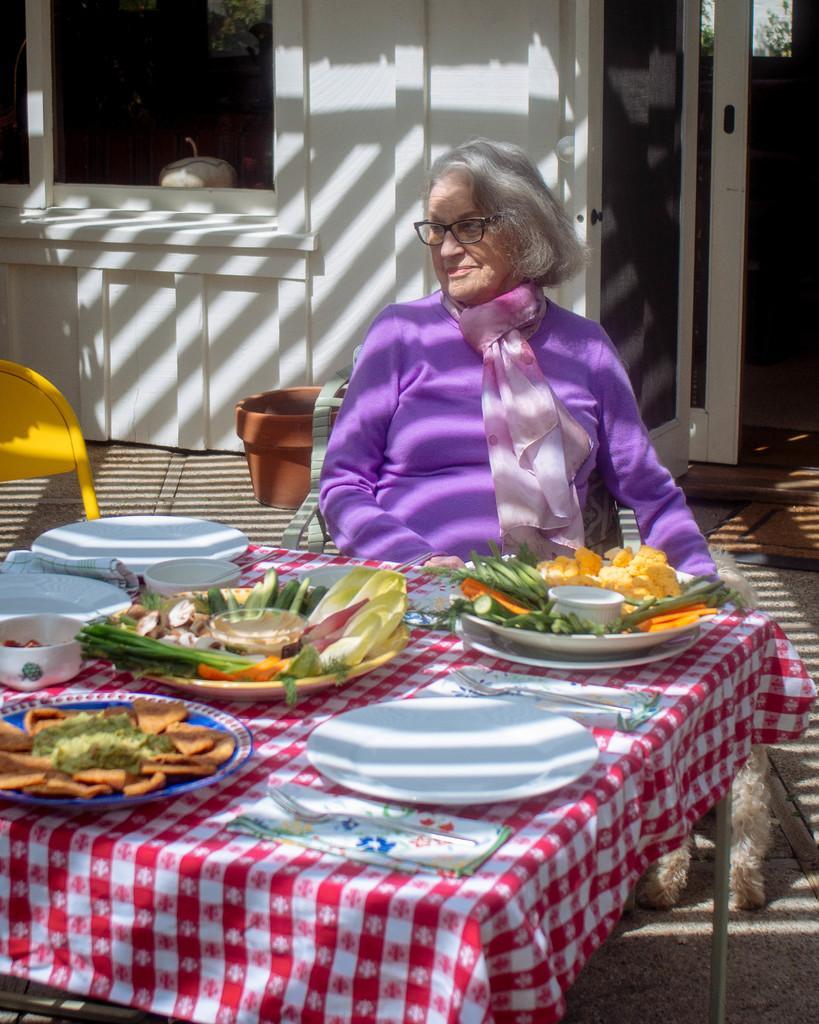Could you give a brief overview of what you see in this image? In this image I can see a person with violet dress is sitting in front of the table. On the table there are plates with food and bowls. The table is covered with red sheet. There is a yellow chair to the left. In the back there is a pot and the building. 